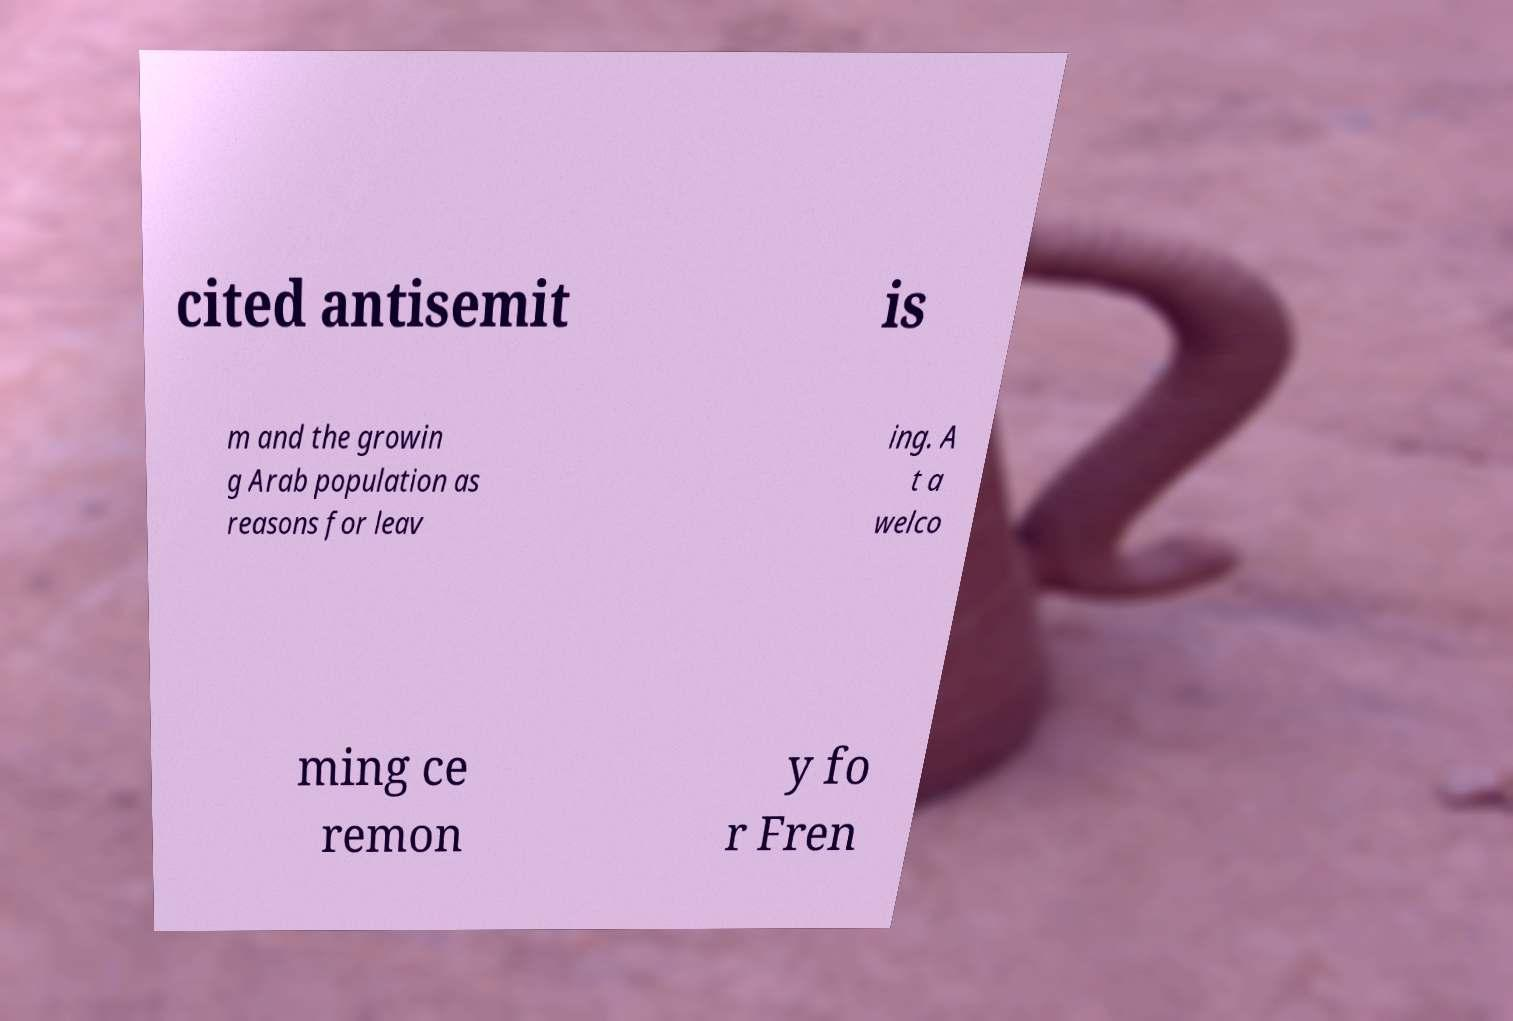Can you read and provide the text displayed in the image?This photo seems to have some interesting text. Can you extract and type it out for me? cited antisemit is m and the growin g Arab population as reasons for leav ing. A t a welco ming ce remon y fo r Fren 